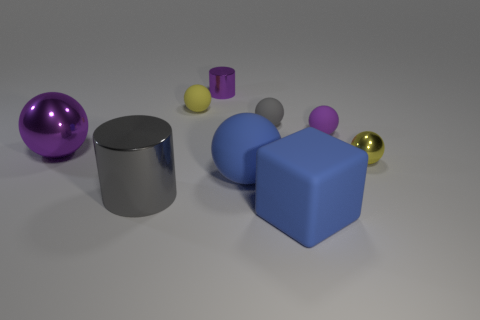Do the small purple object that is on the left side of the large cube and the gray thing that is in front of the big blue matte sphere have the same shape?
Your response must be concise. Yes. What number of balls are both in front of the small purple rubber ball and to the left of the blue block?
Give a very brief answer. 2. Are there any tiny matte things of the same color as the large cylinder?
Offer a very short reply. Yes. There is a gray object that is the same size as the purple shiny ball; what shape is it?
Make the answer very short. Cylinder. Are there any big blue things behind the big gray cylinder?
Keep it short and to the point. Yes. Does the sphere right of the purple rubber sphere have the same material as the yellow sphere that is behind the small purple ball?
Offer a very short reply. No. What number of cylinders are the same size as the yellow shiny object?
Your answer should be compact. 1. There is a small object that is the same color as the large shiny cylinder; what shape is it?
Your answer should be compact. Sphere. There is a yellow object on the left side of the small metal ball; what is it made of?
Provide a succinct answer. Rubber. What number of big matte objects have the same shape as the yellow metallic object?
Your response must be concise. 1. 